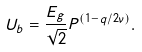<formula> <loc_0><loc_0><loc_500><loc_500>U _ { b } = \frac { E _ { g } } { \sqrt { 2 } } P ^ { ( 1 - q / 2 \nu ) } .</formula> 